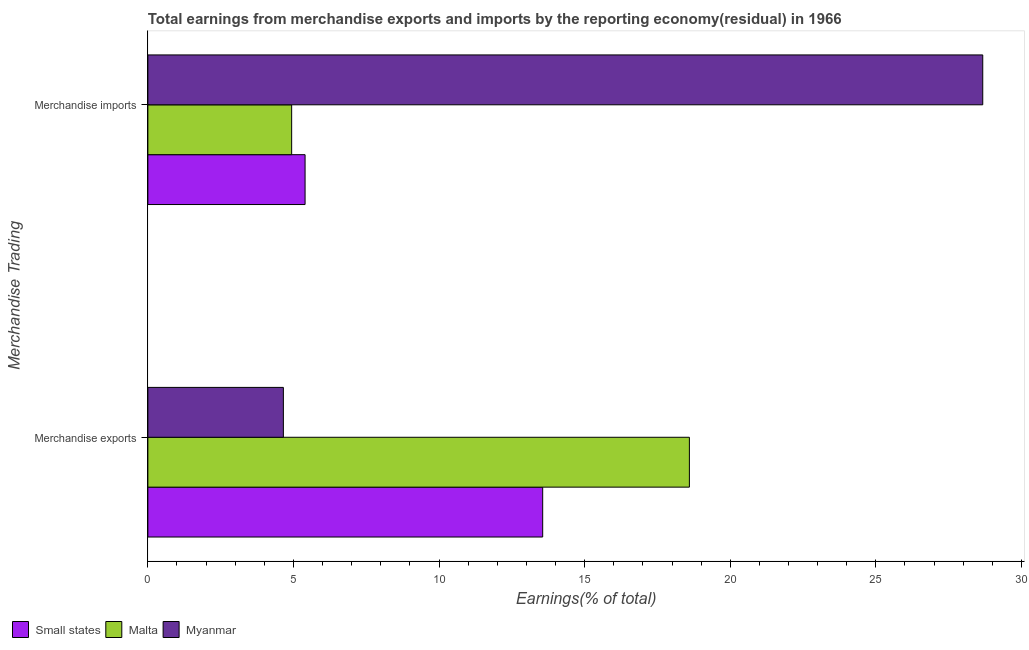How many groups of bars are there?
Provide a succinct answer. 2. How many bars are there on the 2nd tick from the top?
Give a very brief answer. 3. What is the earnings from merchandise exports in Malta?
Give a very brief answer. 18.6. Across all countries, what is the maximum earnings from merchandise imports?
Your answer should be very brief. 28.67. Across all countries, what is the minimum earnings from merchandise imports?
Make the answer very short. 4.94. In which country was the earnings from merchandise exports maximum?
Your answer should be compact. Malta. In which country was the earnings from merchandise exports minimum?
Ensure brevity in your answer.  Myanmar. What is the total earnings from merchandise imports in the graph?
Your answer should be compact. 39.01. What is the difference between the earnings from merchandise exports in Malta and that in Myanmar?
Give a very brief answer. 13.94. What is the difference between the earnings from merchandise imports in Malta and the earnings from merchandise exports in Myanmar?
Ensure brevity in your answer.  0.28. What is the average earnings from merchandise imports per country?
Make the answer very short. 13. What is the difference between the earnings from merchandise imports and earnings from merchandise exports in Myanmar?
Provide a short and direct response. 24.02. In how many countries, is the earnings from merchandise exports greater than 20 %?
Ensure brevity in your answer.  0. What is the ratio of the earnings from merchandise imports in Malta to that in Myanmar?
Ensure brevity in your answer.  0.17. Is the earnings from merchandise exports in Myanmar less than that in Malta?
Your answer should be very brief. Yes. What does the 1st bar from the top in Merchandise exports represents?
Provide a succinct answer. Myanmar. What does the 2nd bar from the bottom in Merchandise imports represents?
Provide a succinct answer. Malta. How many countries are there in the graph?
Your answer should be very brief. 3. What is the difference between two consecutive major ticks on the X-axis?
Give a very brief answer. 5. Does the graph contain any zero values?
Make the answer very short. No. Where does the legend appear in the graph?
Provide a short and direct response. Bottom left. How many legend labels are there?
Ensure brevity in your answer.  3. What is the title of the graph?
Give a very brief answer. Total earnings from merchandise exports and imports by the reporting economy(residual) in 1966. What is the label or title of the X-axis?
Your answer should be very brief. Earnings(% of total). What is the label or title of the Y-axis?
Offer a terse response. Merchandise Trading. What is the Earnings(% of total) of Small states in Merchandise exports?
Provide a succinct answer. 13.56. What is the Earnings(% of total) in Malta in Merchandise exports?
Your answer should be very brief. 18.6. What is the Earnings(% of total) in Myanmar in Merchandise exports?
Offer a very short reply. 4.65. What is the Earnings(% of total) of Small states in Merchandise imports?
Provide a succinct answer. 5.4. What is the Earnings(% of total) of Malta in Merchandise imports?
Offer a terse response. 4.94. What is the Earnings(% of total) of Myanmar in Merchandise imports?
Make the answer very short. 28.67. Across all Merchandise Trading, what is the maximum Earnings(% of total) of Small states?
Keep it short and to the point. 13.56. Across all Merchandise Trading, what is the maximum Earnings(% of total) of Malta?
Your answer should be compact. 18.6. Across all Merchandise Trading, what is the maximum Earnings(% of total) in Myanmar?
Keep it short and to the point. 28.67. Across all Merchandise Trading, what is the minimum Earnings(% of total) in Small states?
Ensure brevity in your answer.  5.4. Across all Merchandise Trading, what is the minimum Earnings(% of total) in Malta?
Offer a terse response. 4.94. Across all Merchandise Trading, what is the minimum Earnings(% of total) of Myanmar?
Your answer should be compact. 4.65. What is the total Earnings(% of total) of Small states in the graph?
Ensure brevity in your answer.  18.96. What is the total Earnings(% of total) in Malta in the graph?
Provide a succinct answer. 23.53. What is the total Earnings(% of total) of Myanmar in the graph?
Provide a short and direct response. 33.32. What is the difference between the Earnings(% of total) in Small states in Merchandise exports and that in Merchandise imports?
Offer a terse response. 8.16. What is the difference between the Earnings(% of total) of Malta in Merchandise exports and that in Merchandise imports?
Ensure brevity in your answer.  13.66. What is the difference between the Earnings(% of total) of Myanmar in Merchandise exports and that in Merchandise imports?
Offer a very short reply. -24.02. What is the difference between the Earnings(% of total) of Small states in Merchandise exports and the Earnings(% of total) of Malta in Merchandise imports?
Provide a short and direct response. 8.62. What is the difference between the Earnings(% of total) in Small states in Merchandise exports and the Earnings(% of total) in Myanmar in Merchandise imports?
Give a very brief answer. -15.11. What is the difference between the Earnings(% of total) in Malta in Merchandise exports and the Earnings(% of total) in Myanmar in Merchandise imports?
Give a very brief answer. -10.07. What is the average Earnings(% of total) in Small states per Merchandise Trading?
Offer a very short reply. 9.48. What is the average Earnings(% of total) of Malta per Merchandise Trading?
Provide a short and direct response. 11.77. What is the average Earnings(% of total) in Myanmar per Merchandise Trading?
Your answer should be compact. 16.66. What is the difference between the Earnings(% of total) of Small states and Earnings(% of total) of Malta in Merchandise exports?
Provide a succinct answer. -5.04. What is the difference between the Earnings(% of total) in Small states and Earnings(% of total) in Myanmar in Merchandise exports?
Keep it short and to the point. 8.9. What is the difference between the Earnings(% of total) of Malta and Earnings(% of total) of Myanmar in Merchandise exports?
Make the answer very short. 13.94. What is the difference between the Earnings(% of total) of Small states and Earnings(% of total) of Malta in Merchandise imports?
Offer a very short reply. 0.46. What is the difference between the Earnings(% of total) of Small states and Earnings(% of total) of Myanmar in Merchandise imports?
Keep it short and to the point. -23.27. What is the difference between the Earnings(% of total) in Malta and Earnings(% of total) in Myanmar in Merchandise imports?
Make the answer very short. -23.73. What is the ratio of the Earnings(% of total) in Small states in Merchandise exports to that in Merchandise imports?
Give a very brief answer. 2.51. What is the ratio of the Earnings(% of total) in Malta in Merchandise exports to that in Merchandise imports?
Offer a very short reply. 3.77. What is the ratio of the Earnings(% of total) of Myanmar in Merchandise exports to that in Merchandise imports?
Keep it short and to the point. 0.16. What is the difference between the highest and the second highest Earnings(% of total) of Small states?
Make the answer very short. 8.16. What is the difference between the highest and the second highest Earnings(% of total) of Malta?
Offer a terse response. 13.66. What is the difference between the highest and the second highest Earnings(% of total) in Myanmar?
Your response must be concise. 24.02. What is the difference between the highest and the lowest Earnings(% of total) in Small states?
Provide a succinct answer. 8.16. What is the difference between the highest and the lowest Earnings(% of total) of Malta?
Give a very brief answer. 13.66. What is the difference between the highest and the lowest Earnings(% of total) in Myanmar?
Offer a terse response. 24.02. 